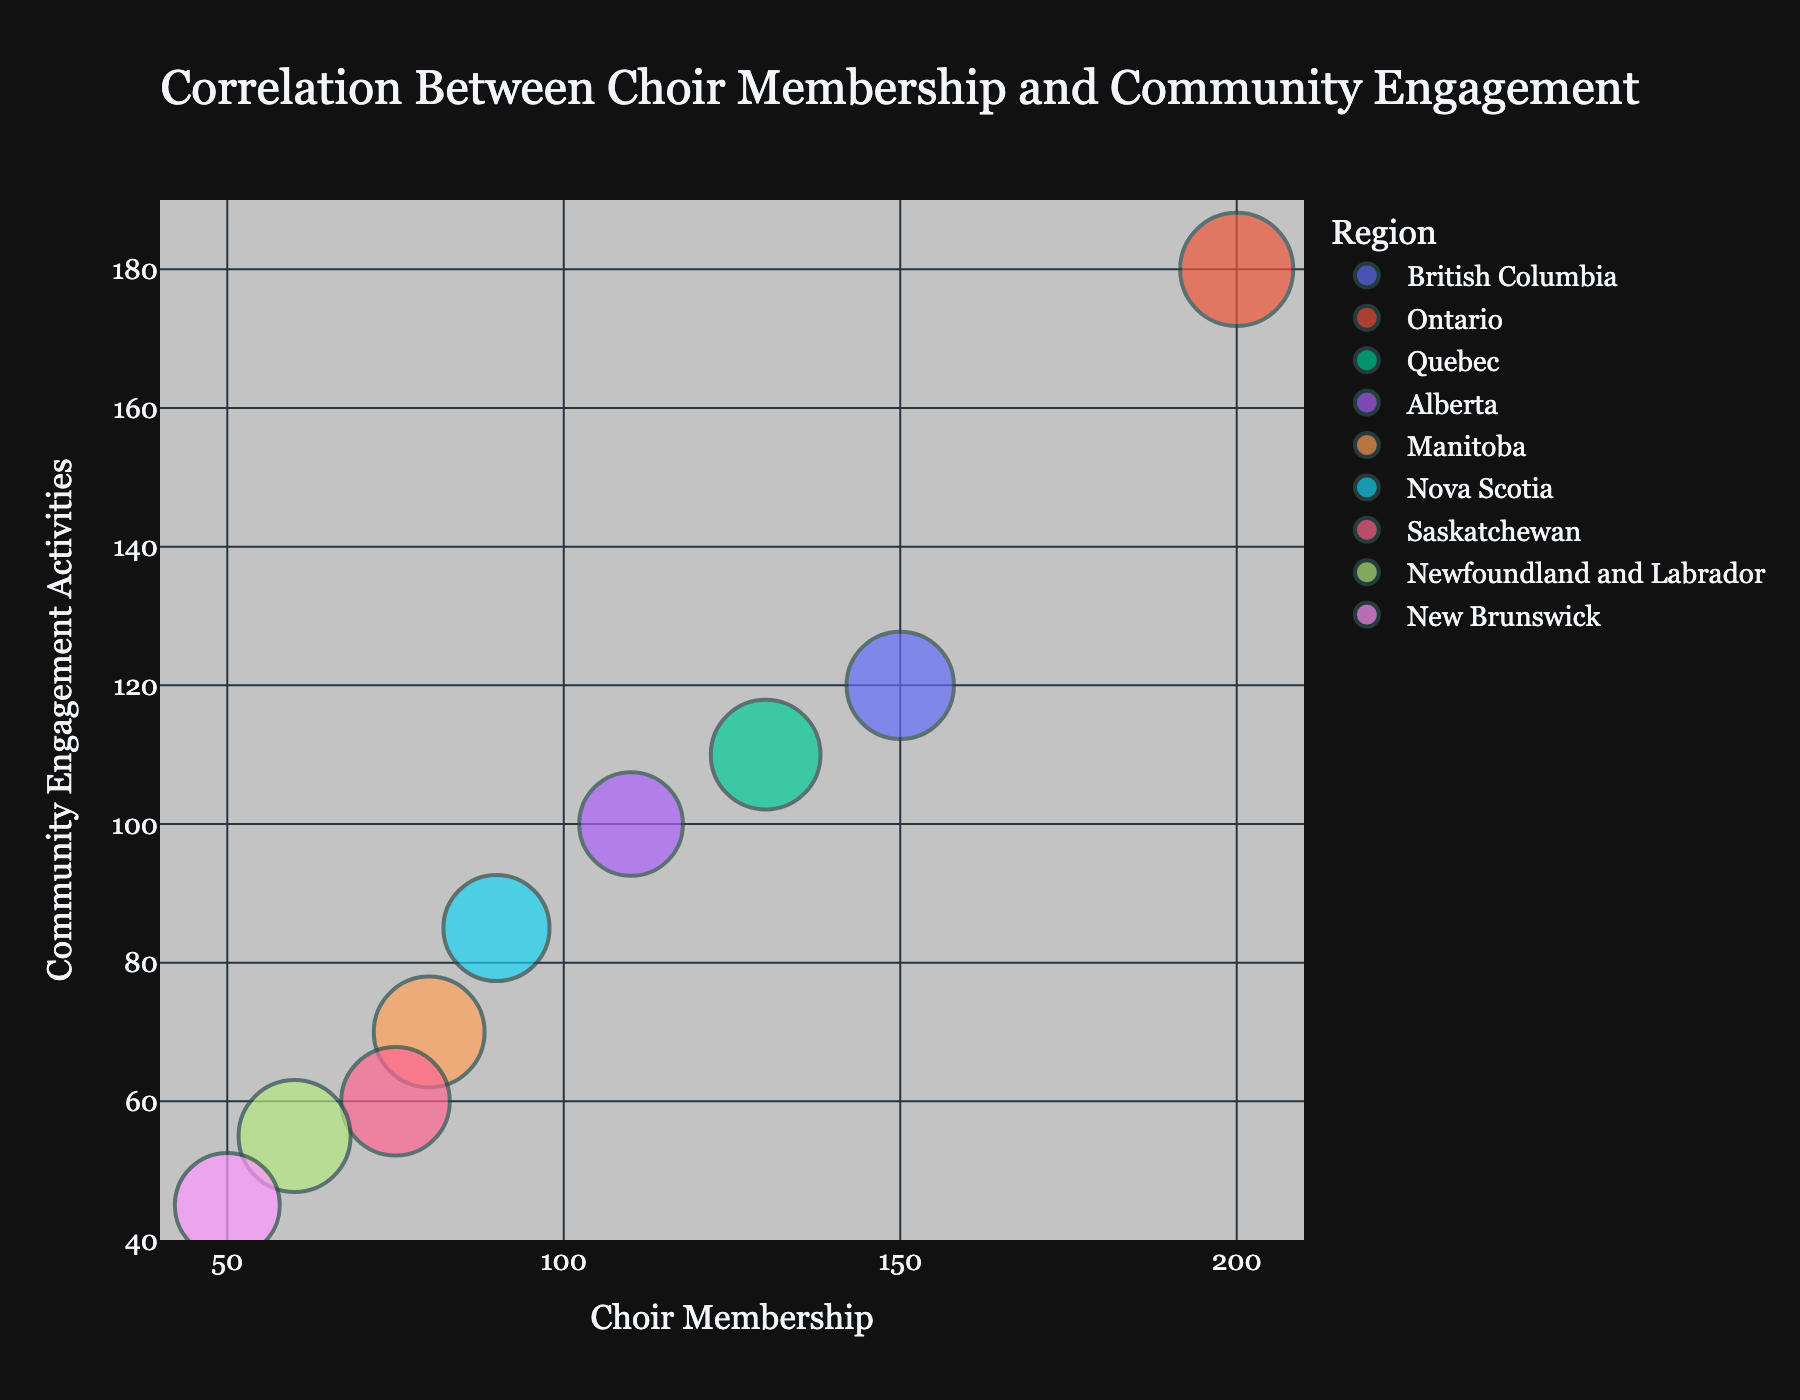Which city has the highest choir membership? Look for the city with the largest bubble along the x-axis, which corresponds to choir membership. Vancouver has the highest choir membership.
Answer: Vancouver What is the title of the chart? Refer to the top section of the chart where the title is displayed. The title is "Correlation Between Choir Membership and Community Engagement."
Answer: Correlation Between Choir Membership and Community Engagement Which region and city have the smallest number of community engagement activities? Identify the smallest bubble along the y-axis, representing community engagement activities. In this case, it is Fredericton in New Brunswick.
Answer: New Brunswick, Fredericton How does Toronto compare to Vancouver in terms of community engagement activities? Compare the positions of Toronto and Vancouver bubbles along the y-axis. Toronto scores higher on the y-axis than Vancouver, indicating more community engagement activities.
Answer: Toronto has more community engagement activities than Vancouver What is the average choir membership across all cities? Add up the choir membership numbers of all cities and divide by the number of cities: (150 + 200 + 130 + 110 + 80 + 90 + 75 + 60 + 50) / 9 = 1044 / 9 = 116.
Answer: 116 Which city has the largest bubble size in the chart? Identify the city that has the largest bubbles by checking the bubble sizes which represent the average age. Toronto has the largest bubbles.
Answer: Toronto Which region dominates the top right part of the chart? Determine which region’s bubbles are mostly in the top-right region, indicating high values in both choir membership and community engagement activities. Ontario (Toronto) is in the top right.
Answer: Ontario Is there a positive or negative trend between choir membership and community engagement activities? Observe the overall direction of the points in the chart as you move along the x-axis (choir membership). The trend is upward from left to right, indicating a positive correlation.
Answer: Positive trend What is the range for average age in this chart? Determine the smallest and largest bubble markers, which represent the average age. The smallest value is New Brunswick (45) and the largest is Newfoundland and Labrador (49).
Answer: 43 to 50 Which city has the smallest bubble size, and what does that represent? Find the smallest bubble which represents the smallest average age. Fredericton in New Brunswick has the smallest bubble indicating the smallest average age.
Answer: Fredericton, representing an average age of 43 